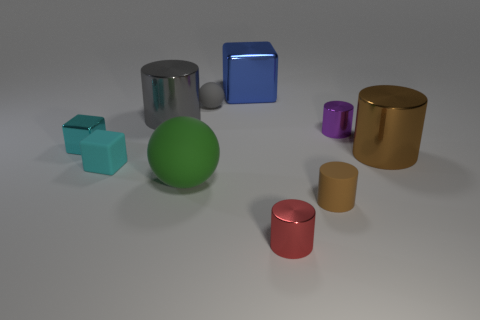Are there any small cyan matte blocks that are on the left side of the tiny matte thing left of the big cylinder that is left of the green rubber ball?
Provide a succinct answer. No. What number of other objects are there of the same color as the big rubber ball?
Make the answer very short. 0. There is a metallic block that is left of the green matte thing; is its size the same as the ball that is behind the green object?
Ensure brevity in your answer.  Yes. Are there an equal number of large matte balls on the right side of the big metallic block and tiny purple objects that are in front of the small brown thing?
Offer a very short reply. Yes. Are there any other things that are made of the same material as the purple cylinder?
Your answer should be compact. Yes. Does the cyan matte thing have the same size as the gray object right of the large rubber ball?
Your response must be concise. Yes. What material is the brown thing behind the sphere that is in front of the brown shiny cylinder?
Keep it short and to the point. Metal. Are there the same number of metallic cylinders in front of the small cyan rubber block and small purple objects?
Ensure brevity in your answer.  Yes. How big is the shiny object that is behind the cyan shiny cube and on the right side of the red cylinder?
Keep it short and to the point. Small. What is the color of the big cylinder in front of the big cylinder on the left side of the blue shiny cube?
Your response must be concise. Brown. 